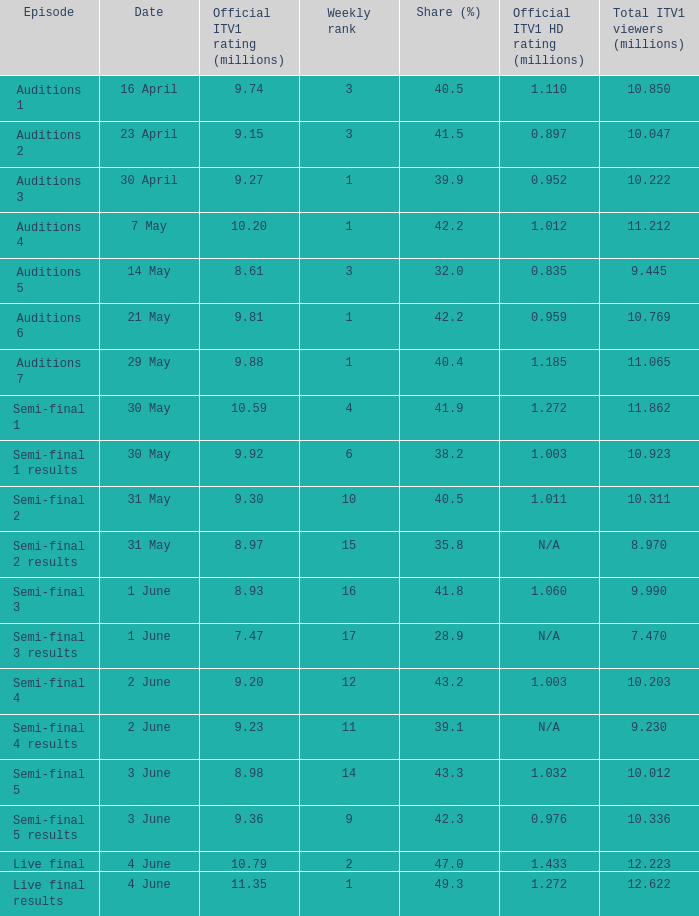Help me parse the entirety of this table. {'header': ['Episode', 'Date', 'Official ITV1 rating (millions)', 'Weekly rank', 'Share (%)', 'Official ITV1 HD rating (millions)', 'Total ITV1 viewers (millions)'], 'rows': [['Auditions 1', '16 April', '9.74', '3', '40.5', '1.110', '10.850'], ['Auditions 2', '23 April', '9.15', '3', '41.5', '0.897', '10.047'], ['Auditions 3', '30 April', '9.27', '1', '39.9', '0.952', '10.222'], ['Auditions 4', '7 May', '10.20', '1', '42.2', '1.012', '11.212'], ['Auditions 5', '14 May', '8.61', '3', '32.0', '0.835', '9.445'], ['Auditions 6', '21 May', '9.81', '1', '42.2', '0.959', '10.769'], ['Auditions 7', '29 May', '9.88', '1', '40.4', '1.185', '11.065'], ['Semi-final 1', '30 May', '10.59', '4', '41.9', '1.272', '11.862'], ['Semi-final 1 results', '30 May', '9.92', '6', '38.2', '1.003', '10.923'], ['Semi-final 2', '31 May', '9.30', '10', '40.5', '1.011', '10.311'], ['Semi-final 2 results', '31 May', '8.97', '15', '35.8', 'N/A', '8.970'], ['Semi-final 3', '1 June', '8.93', '16', '41.8', '1.060', '9.990'], ['Semi-final 3 results', '1 June', '7.47', '17', '28.9', 'N/A', '7.470'], ['Semi-final 4', '2 June', '9.20', '12', '43.2', '1.003', '10.203'], ['Semi-final 4 results', '2 June', '9.23', '11', '39.1', 'N/A', '9.230'], ['Semi-final 5', '3 June', '8.98', '14', '43.3', '1.032', '10.012'], ['Semi-final 5 results', '3 June', '9.36', '9', '42.3', '0.976', '10.336'], ['Live final', '4 June', '10.79', '2', '47.0', '1.433', '12.223'], ['Live final results', '4 June', '11.35', '1', '49.3', '1.272', '12.622']]} 98 million? 1.032. 